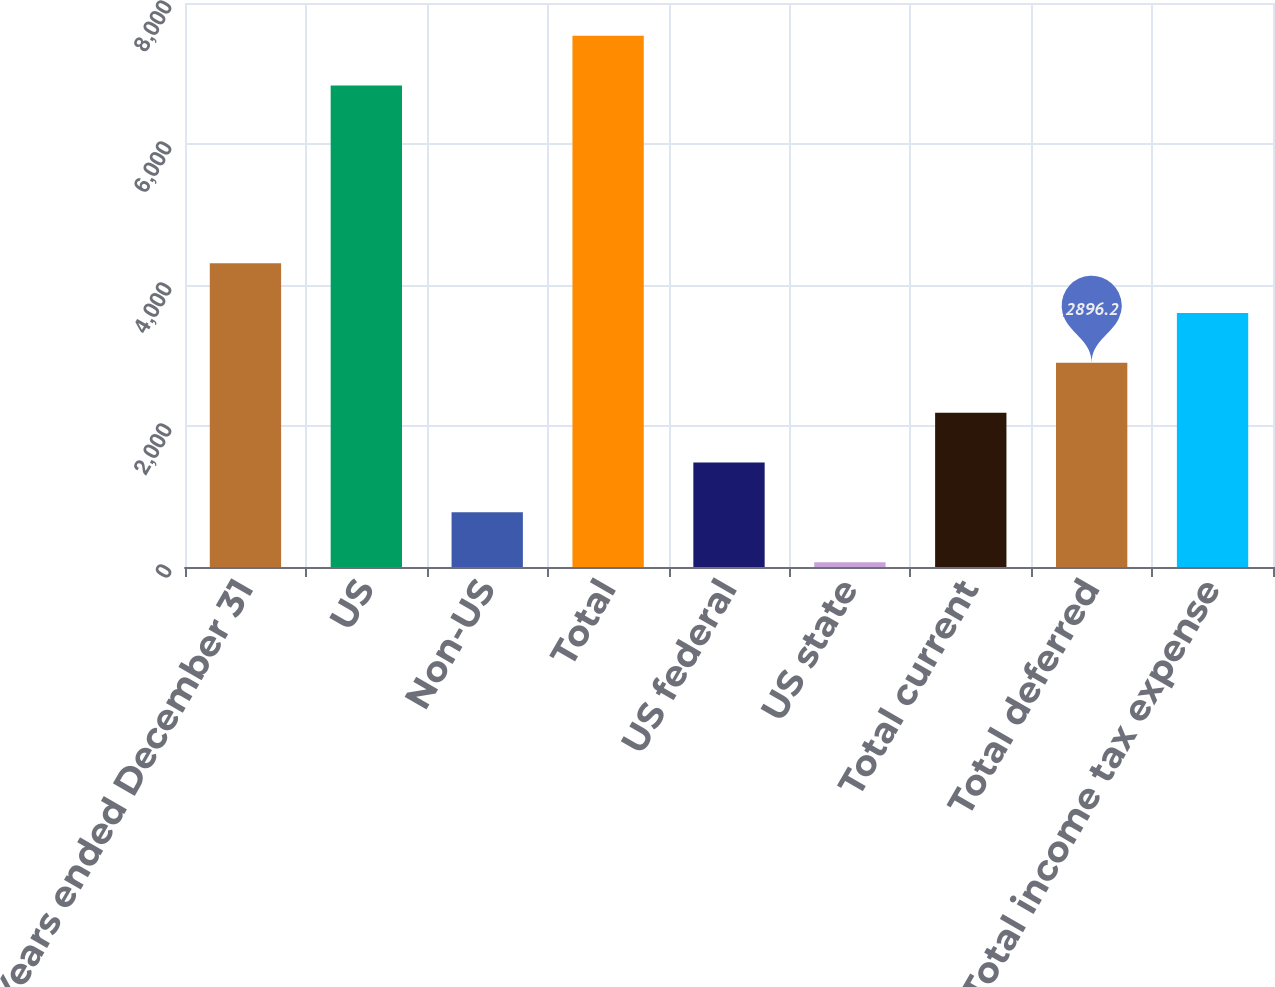<chart> <loc_0><loc_0><loc_500><loc_500><bar_chart><fcel>Years ended December 31<fcel>US<fcel>Non-US<fcel>Total<fcel>US federal<fcel>US state<fcel>Total current<fcel>Total deferred<fcel>Total income tax expense<nl><fcel>4309.8<fcel>6829<fcel>775.8<fcel>7535.8<fcel>1482.6<fcel>69<fcel>2189.4<fcel>2896.2<fcel>3603<nl></chart> 